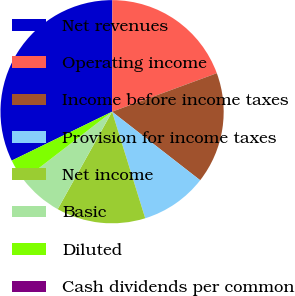Convert chart to OTSL. <chart><loc_0><loc_0><loc_500><loc_500><pie_chart><fcel>Net revenues<fcel>Operating income<fcel>Income before income taxes<fcel>Provision for income taxes<fcel>Net income<fcel>Basic<fcel>Diluted<fcel>Cash dividends per common<nl><fcel>32.26%<fcel>19.35%<fcel>16.13%<fcel>9.68%<fcel>12.9%<fcel>6.45%<fcel>3.23%<fcel>0.0%<nl></chart> 